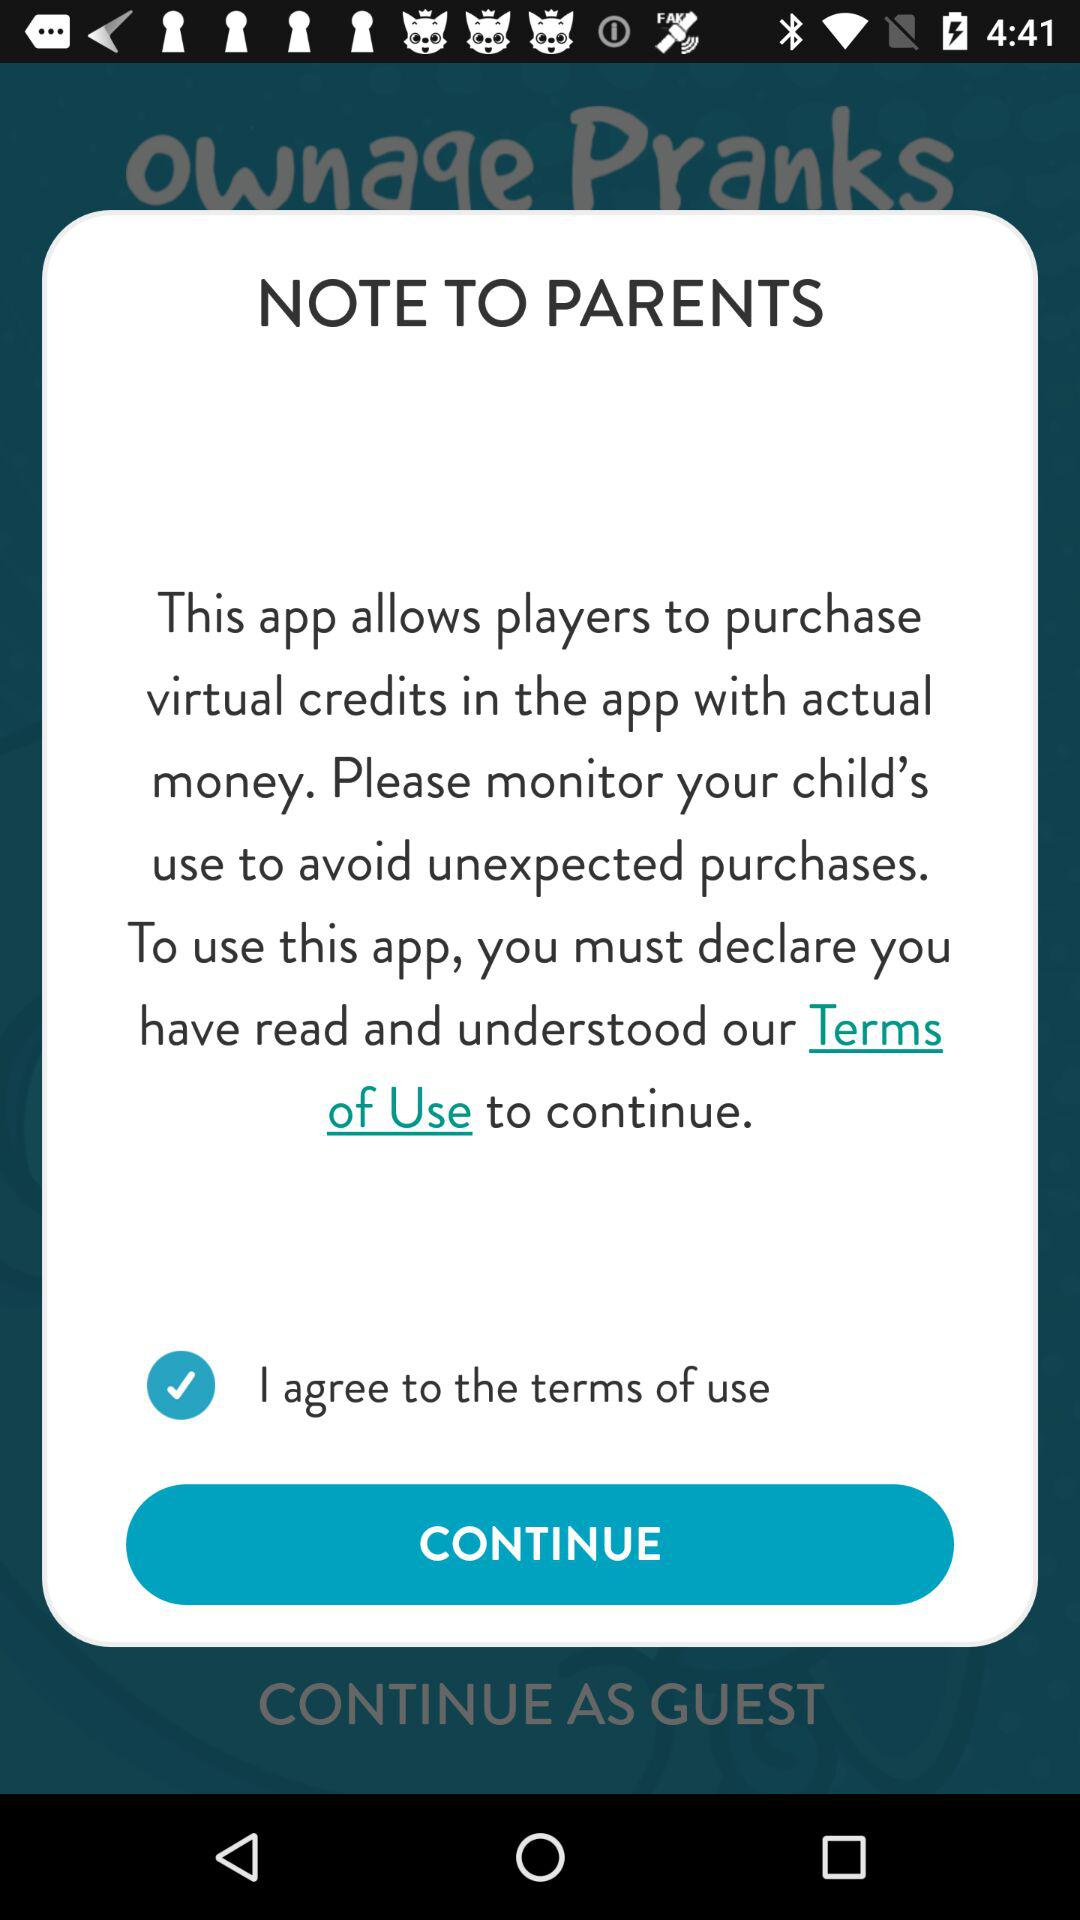What is the status of the option that includes agreement to the “terms of use”? The status is "on". 